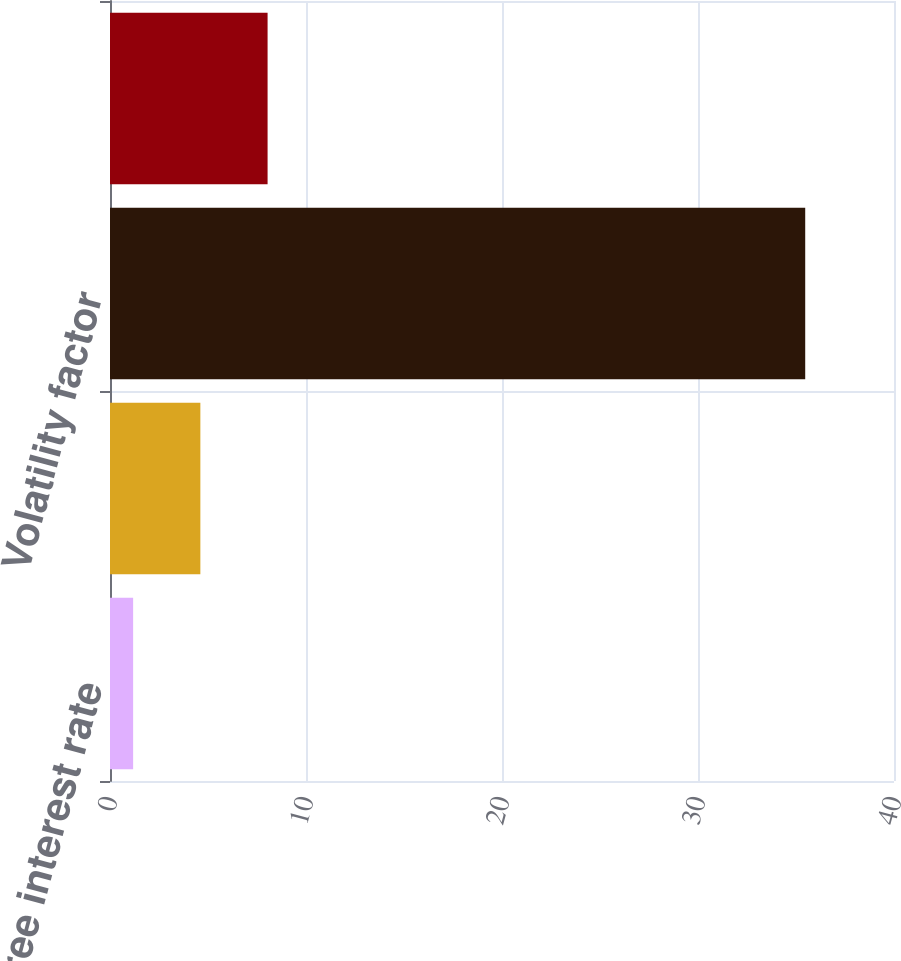<chart> <loc_0><loc_0><loc_500><loc_500><bar_chart><fcel>Risk-free interest rate<fcel>Dividend yield<fcel>Volatility factor<fcel>Expected life (years)<nl><fcel>1.18<fcel>4.61<fcel>35.47<fcel>8.04<nl></chart> 